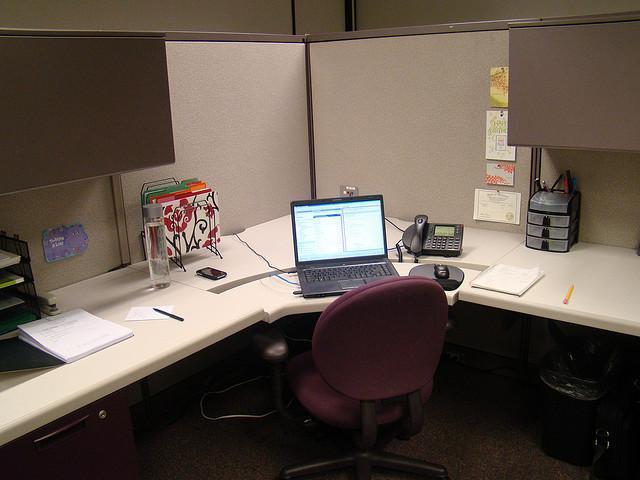How many women are wearing neon green?
Give a very brief answer. 0. 